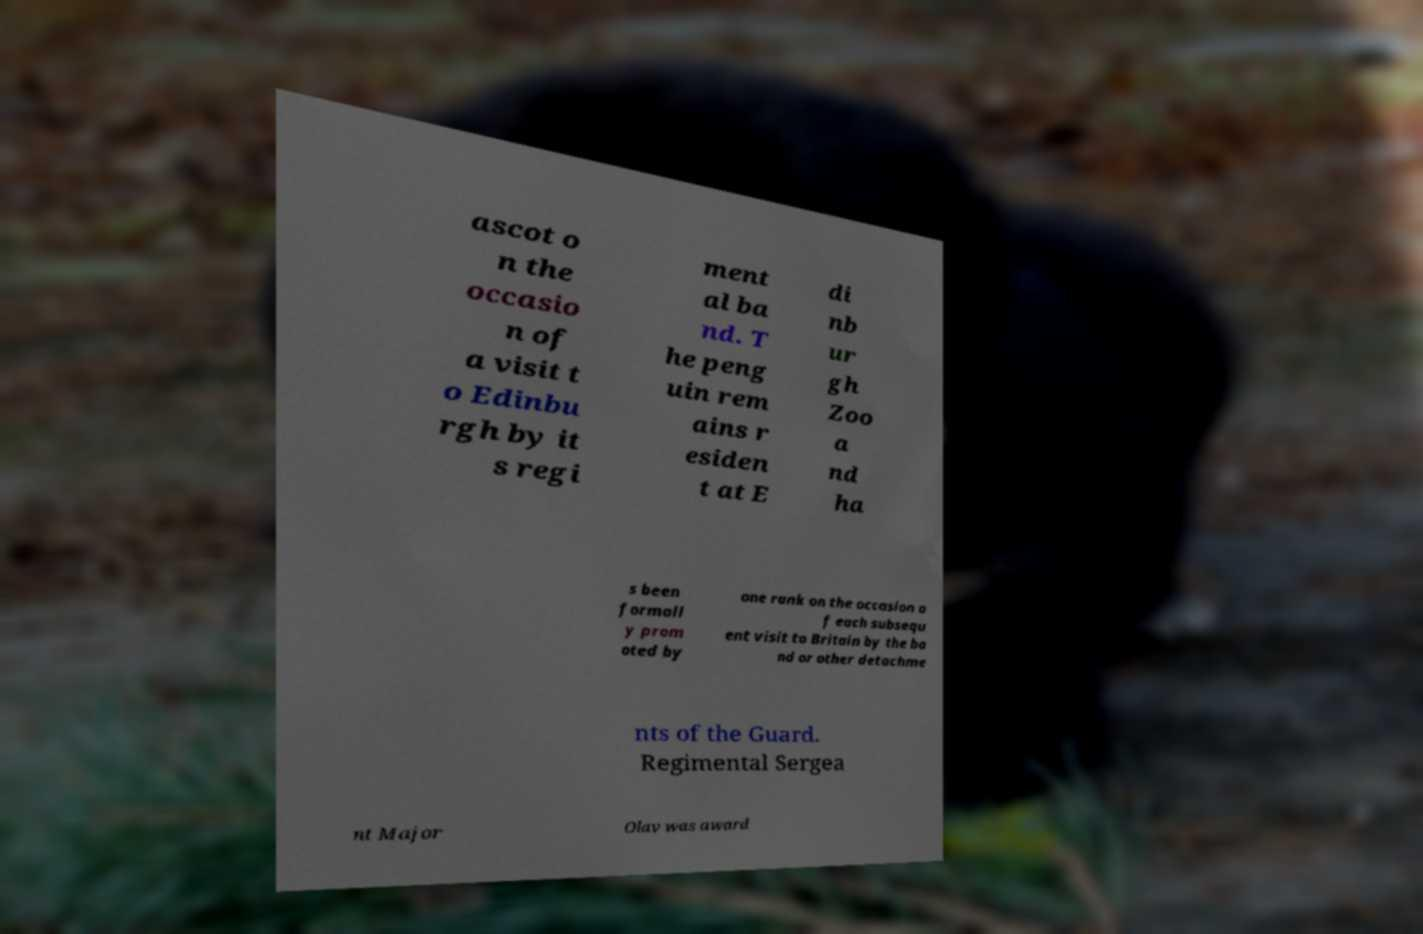Could you extract and type out the text from this image? ascot o n the occasio n of a visit t o Edinbu rgh by it s regi ment al ba nd. T he peng uin rem ains r esiden t at E di nb ur gh Zoo a nd ha s been formall y prom oted by one rank on the occasion o f each subsequ ent visit to Britain by the ba nd or other detachme nts of the Guard. Regimental Sergea nt Major Olav was award 